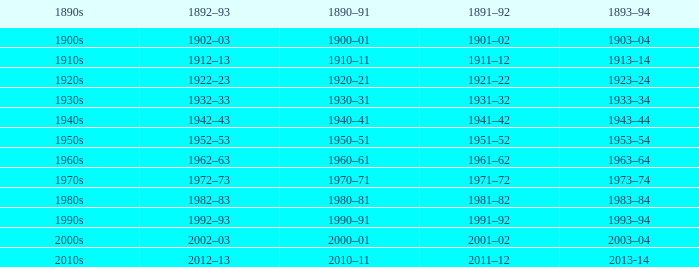What is the year from 1891-92 from the years 1890s to the 1960s? 1961–62. 